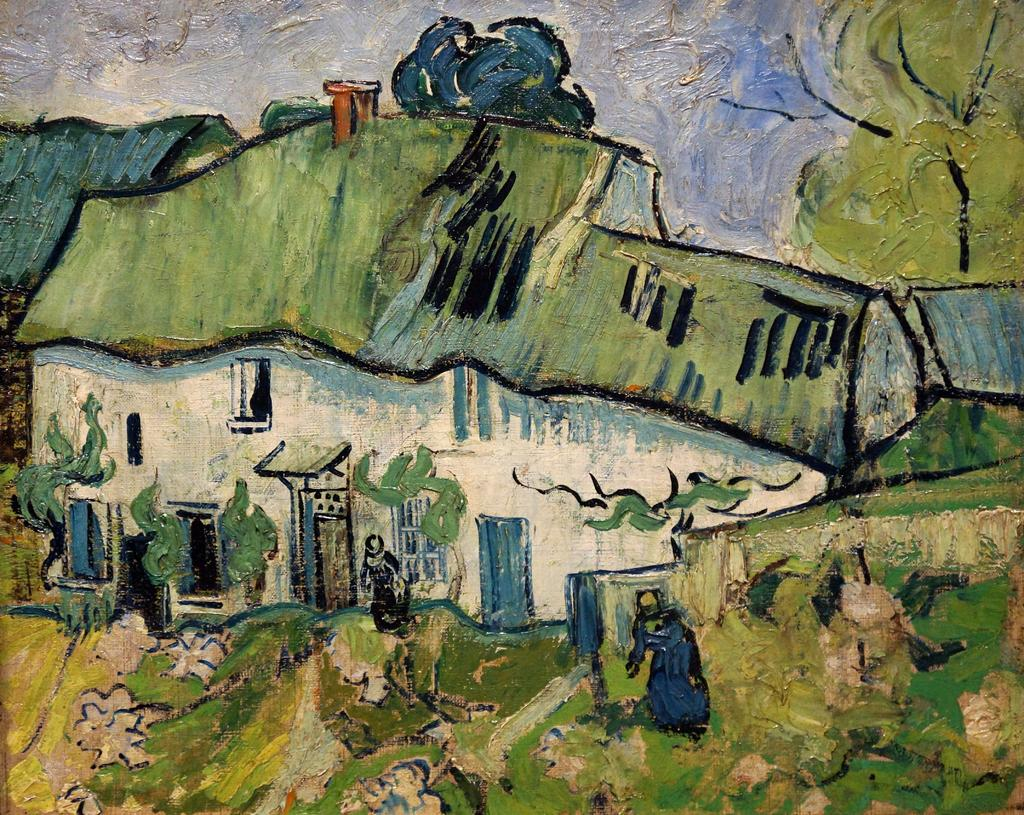What is the main subject of the painting in the image? The painting depicts a house. Are there any living beings in the painting? Yes, the painting includes people. What other natural elements can be seen in the painting? The painting features a tree and the sky is visible. Can you describe any other elements in the painting? There are other unspecified elements in the painting, but we cannot provide specific details without more information. What type of thunder can be heard in the painting? There is no sound present in the painting, so it is not possible to hear thunder or any other sounds. 